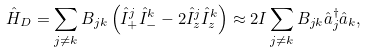<formula> <loc_0><loc_0><loc_500><loc_500>\hat { H } _ { D } = \sum _ { j \ne k } B _ { j k } \left ( \hat { I } ^ { j } _ { + } \hat { I } ^ { k } _ { - } - 2 \hat { I } ^ { j } _ { z } \hat { I } ^ { k } _ { z } \right ) \approx 2 I \sum _ { j \ne k } B _ { j k } \hat { a } _ { j } ^ { \dag } \hat { a } _ { k } ,</formula> 